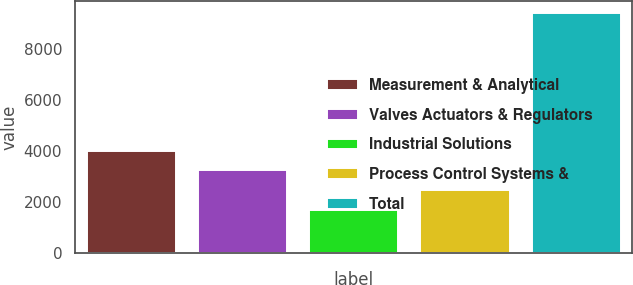Convert chart to OTSL. <chart><loc_0><loc_0><loc_500><loc_500><bar_chart><fcel>Measurement & Analytical<fcel>Valves Actuators & Regulators<fcel>Industrial Solutions<fcel>Process Control Systems &<fcel>Total<nl><fcel>4001.4<fcel>3227.6<fcel>1680<fcel>2453.8<fcel>9418<nl></chart> 